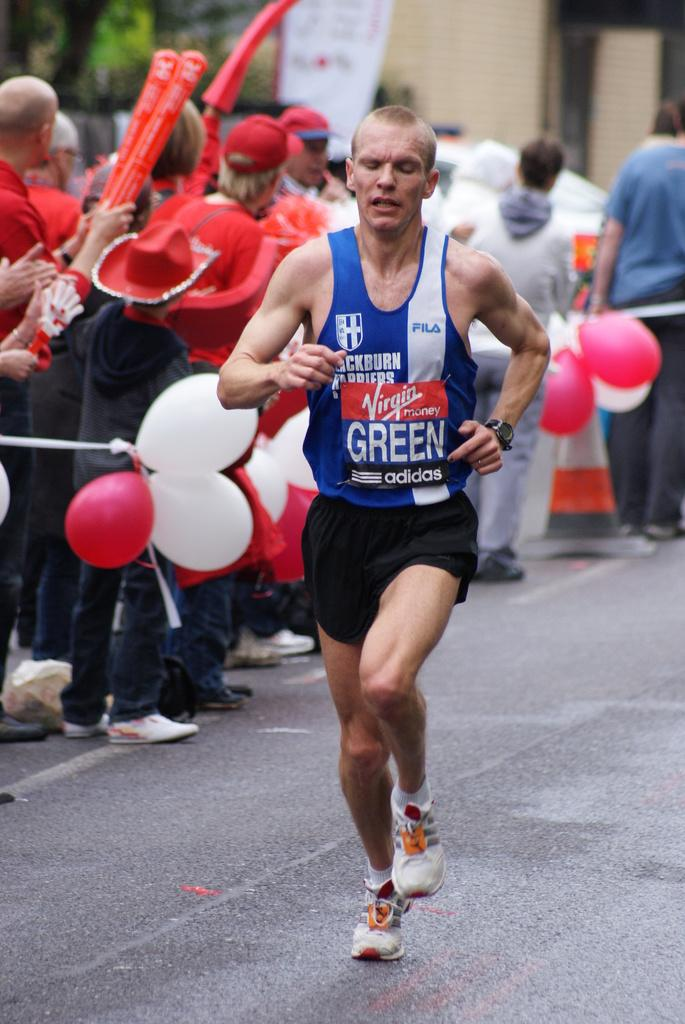<image>
Summarize the visual content of the image. a man running with the word green on his shirt 